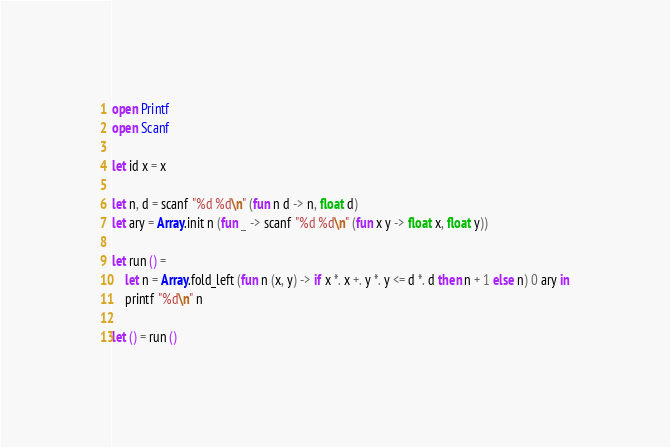Convert code to text. <code><loc_0><loc_0><loc_500><loc_500><_OCaml_>open Printf
open Scanf

let id x = x

let n, d = scanf "%d %d\n" (fun n d -> n, float d)
let ary = Array.init n (fun _ -> scanf "%d %d\n" (fun x y -> float x, float y))

let run () =
    let n = Array.fold_left (fun n (x, y) -> if x *. x +. y *. y <= d *. d then n + 1 else n) 0 ary in
    printf "%d\n" n

let () = run ()
</code> 